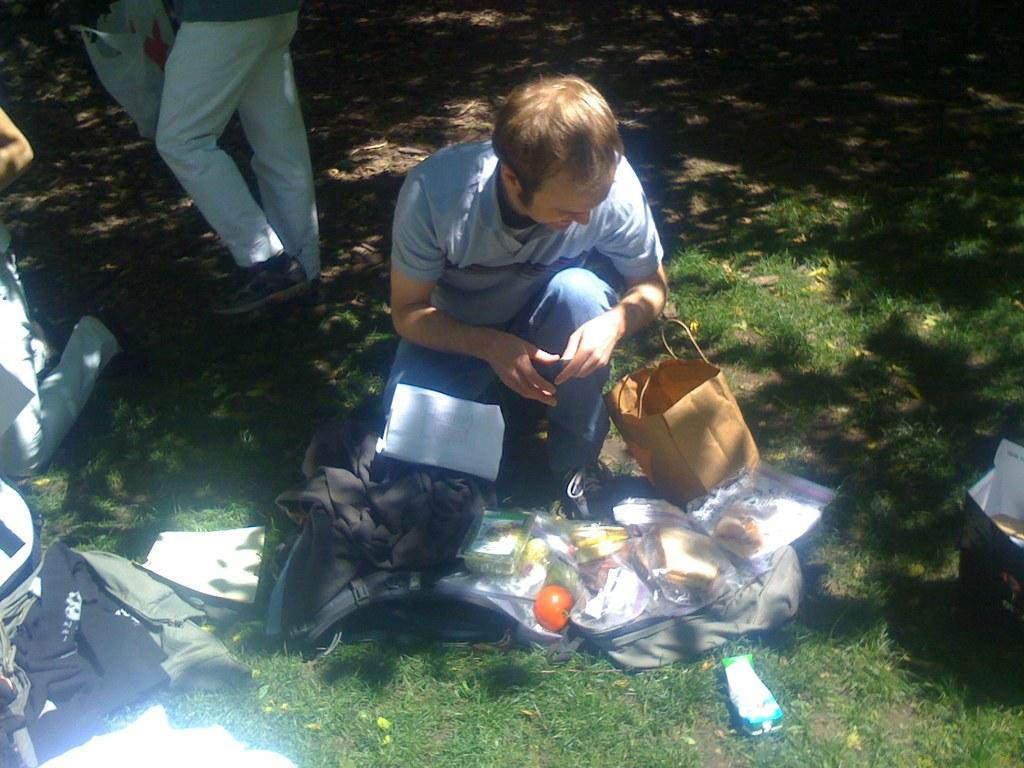What type of objects can be seen in the image? There are food items and a backpack in the image. Where are the food items and backpack located? They are on the grass ground in the image. Are there any people in the image? Yes, there are people present in the image. How many oranges are hanging from the hole in the image? There are no oranges or holes present in the image. 